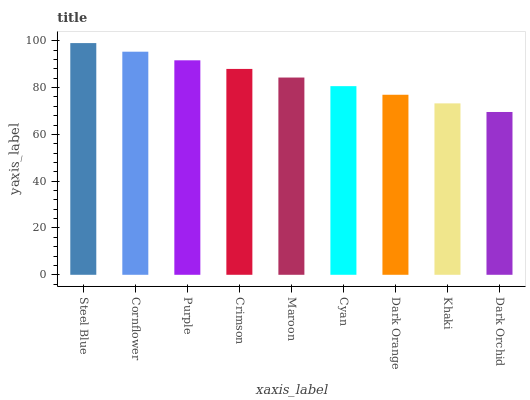Is Dark Orchid the minimum?
Answer yes or no. Yes. Is Steel Blue the maximum?
Answer yes or no. Yes. Is Cornflower the minimum?
Answer yes or no. No. Is Cornflower the maximum?
Answer yes or no. No. Is Steel Blue greater than Cornflower?
Answer yes or no. Yes. Is Cornflower less than Steel Blue?
Answer yes or no. Yes. Is Cornflower greater than Steel Blue?
Answer yes or no. No. Is Steel Blue less than Cornflower?
Answer yes or no. No. Is Maroon the high median?
Answer yes or no. Yes. Is Maroon the low median?
Answer yes or no. Yes. Is Dark Orange the high median?
Answer yes or no. No. Is Cornflower the low median?
Answer yes or no. No. 